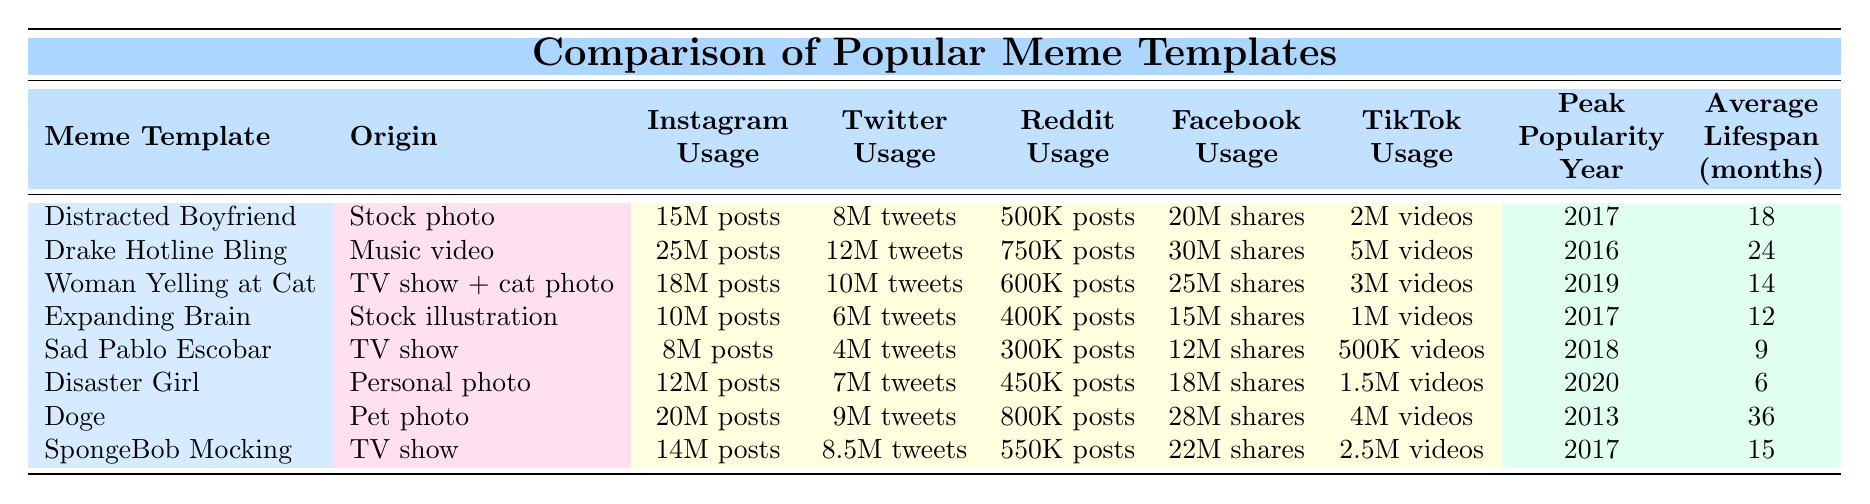What meme template has the highest Instagram usage? By looking at the 'Instagram Usage' column, we see that 'Drake Hotline Bling' has the highest number of posts with 25M, which is more than any other meme template listed.
Answer: Drake Hotline Bling Which meme template has the shortest average lifespan? The 'Average Lifespan (months)' column shows that 'Disaster Girl' has the shortest lifespan of 6 months, making it the meme template that lasts the least amount of time on average.
Answer: Disaster Girl True or False: 'Doge' has more shares on Facebook than 'Sad Pablo Escobar'. By comparing the 'Facebook Usage' values, 'Doge' has 28M shares while 'Sad Pablo Escobar' has 12M shares. Since 28M is greater than 12M, the statement is true.
Answer: True What is the total number of posts for the meme 'Woman Yelling at Cat' across all platforms? The total is calculated by adding the posts from Instagram (18M), Reddit (600K), and Facebook (25M): 18M + 0.6M + 25M = 43.6M posts. Therefore, 'Woman Yelling at Cat' has a total of 43.6M posts across all platforms.
Answer: 43.6M Which meme template had its peak popularity in 2016? By checking the 'Peak Popularity Year' column, we see that 'Drake Hotline Bling' is the only meme template listed that reached its peak popularity in 2016.
Answer: Drake Hotline Bling Which two memes have similar usage on TikTok (around 2M videos)? Looking at the 'TikTok Usage' column, we find that 'Distracted Boyfriend' has 2M videos and 'Expanding Brain' has 1M videos, while 'Sad Pablo Escobar' has only 500K. Thus, 'Distracted Boyfriend' and 'Expanding Brain' are the closest in TikTok usage, but they are not exactly similar.
Answer: None, closest is Distracted Boyfriend (2M) and Expanding Brain (1M) What is the average Twitter usage for all the memes listed? To find the average, calculate the total Twitter usage by summing all the values: 8M + 12M + 10M + 6M + 4M + 7M + 9M + 8.5M = 65.5M. There are 8 templates, so average is 65.5M / 8 = 8.1875M.
Answer: 8.19M 